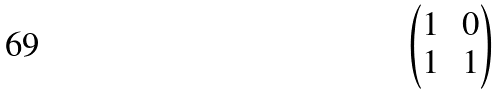<formula> <loc_0><loc_0><loc_500><loc_500>\begin{pmatrix} 1 & \, 0 \\ 1 & \, 1 \end{pmatrix}</formula> 